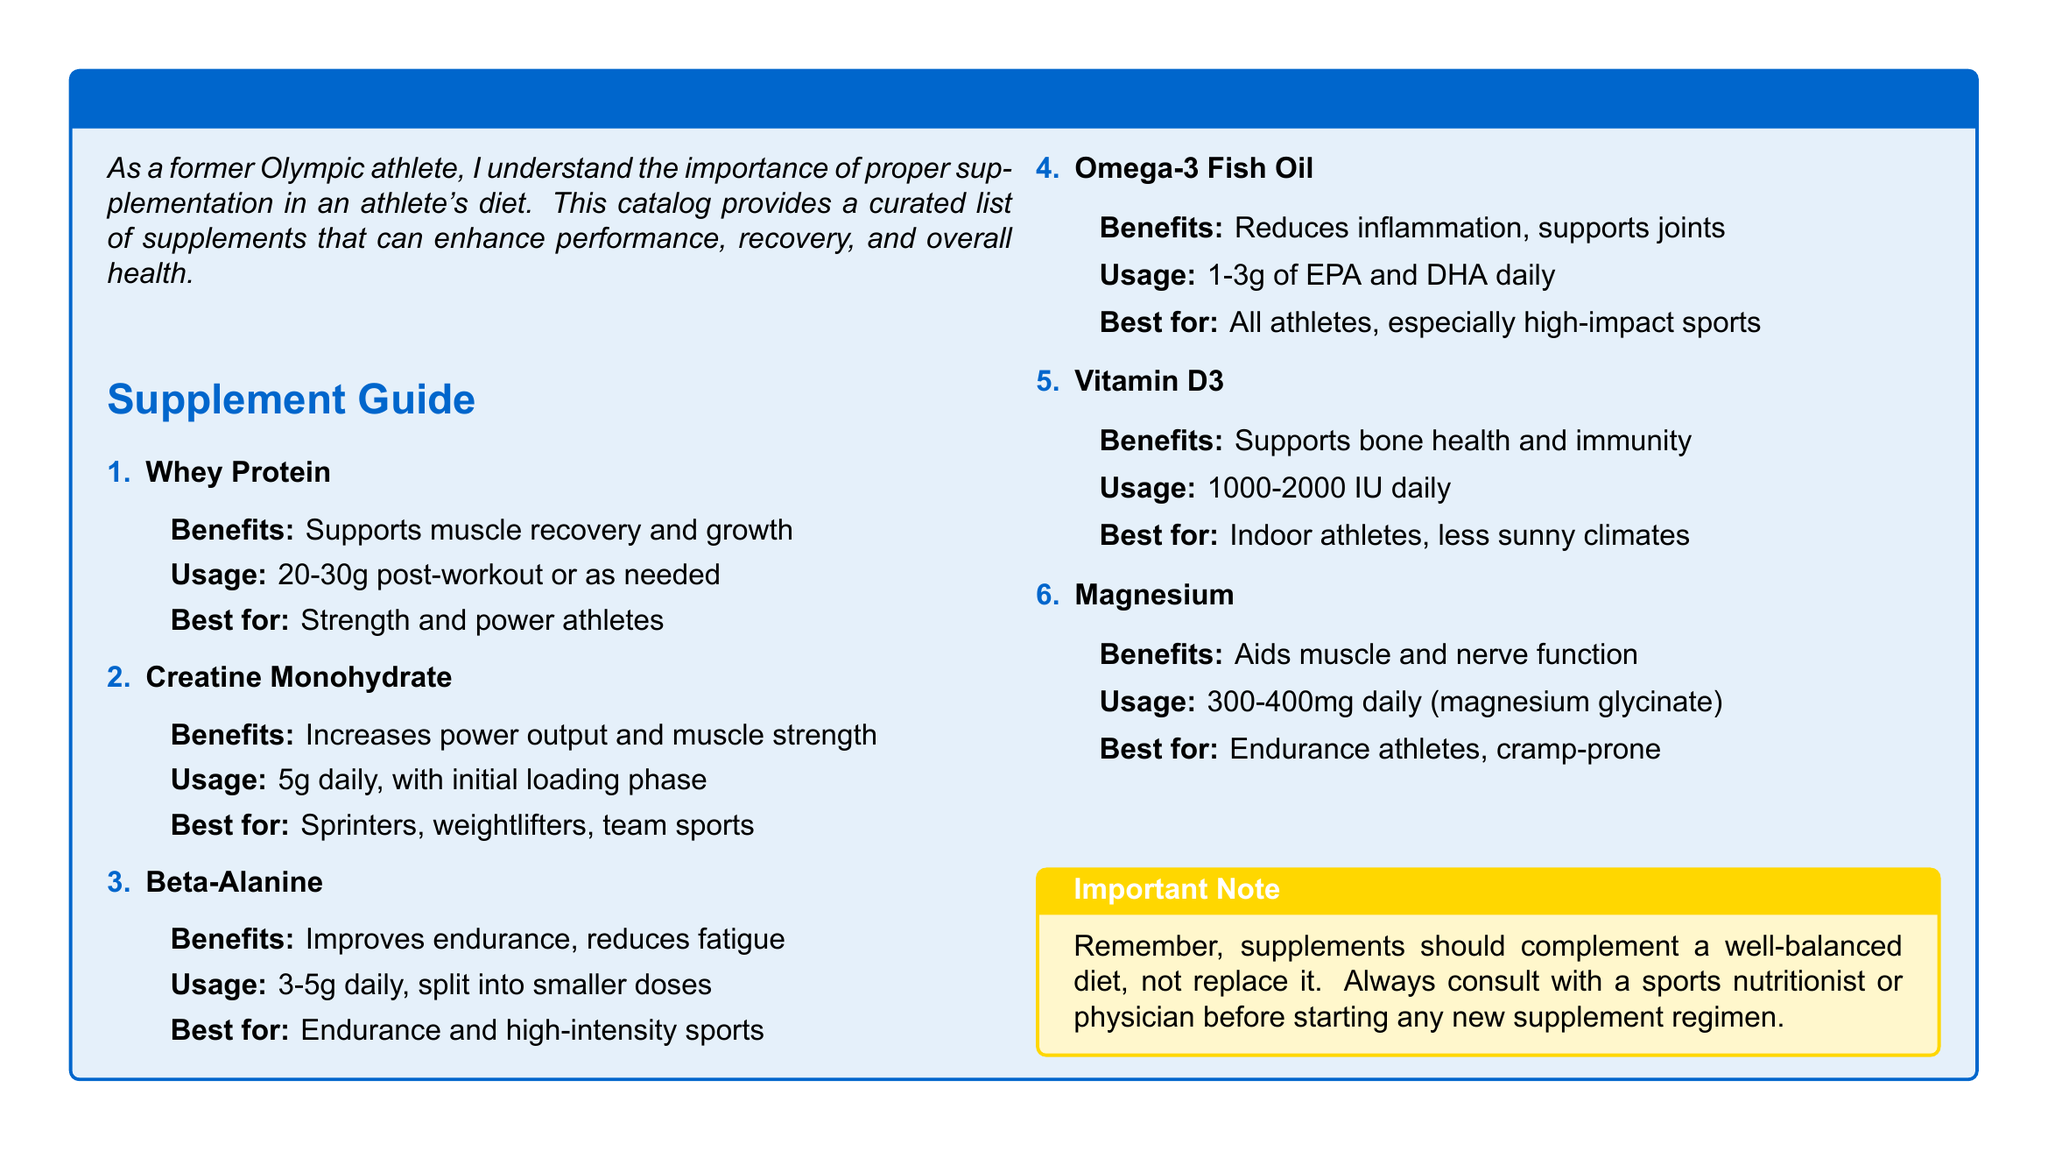What are the benefits of Whey Protein? The document states that Whey Protein supports muscle recovery and growth.
Answer: Supports muscle recovery and growth What is the recommended usage for Beta-Alanine? The recommended usage for Beta-Alanine is 3-5g daily, split into smaller doses.
Answer: 3-5g daily, split into smaller doses Which nutrient is best for indoor athletes? The document indicates that Vitamin D3 is best for indoor athletes, particularly in less sunny climates.
Answer: Vitamin D3 How much Omega-3 Fish Oil should athletes take daily? The catalog recommends 1-3g of EPA and DHA daily for Omega-3 Fish Oil.
Answer: 1-3g of EPA and DHA daily What is the primary benefit of Magnesium? The document highlights that Magnesium aids muscle and nerve function.
Answer: Aids muscle and nerve function Which supplement is specifically indicated for sprinters, weightlifters, and team sports? The document specifies that Creatine Monohydrate is best for sprinters, weightlifters, and team sports.
Answer: Creatine Monohydrate How many grams of Whey Protein are recommended post-workout? The document recommends 20-30g of Whey Protein post-workout.
Answer: 20-30g What color is used for important notes in the document? The catalog uses gold for important notes.
Answer: Gold What should supplements do according to the important note? The document states that supplements should complement a well-balanced diet, not replace it.
Answer: Complement a well-balanced diet, not replace it 